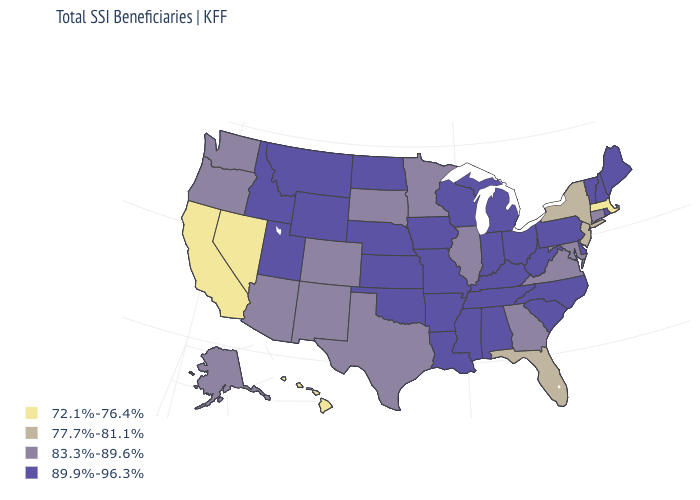What is the value of Massachusetts?
Keep it brief. 72.1%-76.4%. What is the value of California?
Concise answer only. 72.1%-76.4%. Name the states that have a value in the range 72.1%-76.4%?
Quick response, please. California, Hawaii, Massachusetts, Nevada. What is the value of Georgia?
Answer briefly. 83.3%-89.6%. What is the highest value in the USA?
Answer briefly. 89.9%-96.3%. Does New Mexico have a higher value than Hawaii?
Quick response, please. Yes. Name the states that have a value in the range 89.9%-96.3%?
Short answer required. Alabama, Arkansas, Delaware, Idaho, Indiana, Iowa, Kansas, Kentucky, Louisiana, Maine, Michigan, Mississippi, Missouri, Montana, Nebraska, New Hampshire, North Carolina, North Dakota, Ohio, Oklahoma, Pennsylvania, Rhode Island, South Carolina, Tennessee, Utah, Vermont, West Virginia, Wisconsin, Wyoming. What is the value of Georgia?
Answer briefly. 83.3%-89.6%. What is the value of Washington?
Concise answer only. 83.3%-89.6%. Is the legend a continuous bar?
Give a very brief answer. No. Does Minnesota have the highest value in the USA?
Quick response, please. No. Name the states that have a value in the range 89.9%-96.3%?
Concise answer only. Alabama, Arkansas, Delaware, Idaho, Indiana, Iowa, Kansas, Kentucky, Louisiana, Maine, Michigan, Mississippi, Missouri, Montana, Nebraska, New Hampshire, North Carolina, North Dakota, Ohio, Oklahoma, Pennsylvania, Rhode Island, South Carolina, Tennessee, Utah, Vermont, West Virginia, Wisconsin, Wyoming. What is the value of Kentucky?
Concise answer only. 89.9%-96.3%. What is the value of Colorado?
Quick response, please. 83.3%-89.6%. 